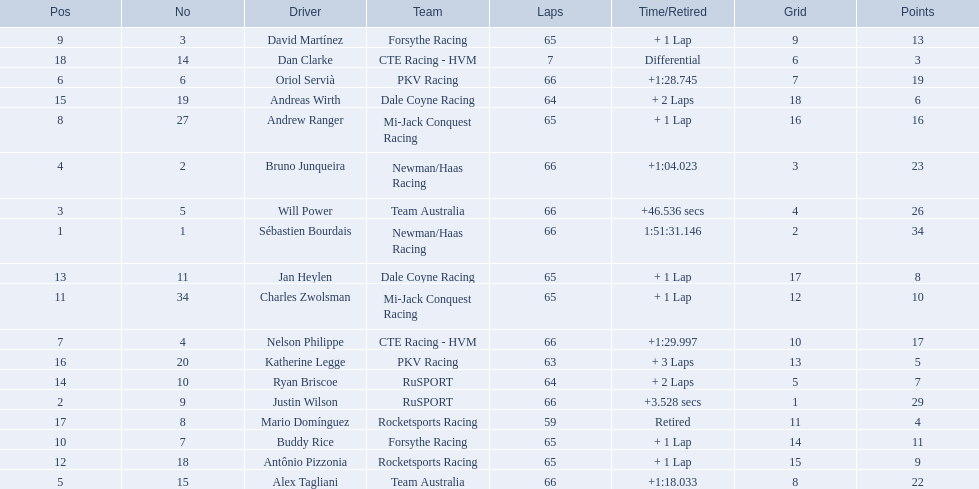Which people scored 29+ points? Sébastien Bourdais, Justin Wilson. Who scored higher? Sébastien Bourdais. Write the full table. {'header': ['Pos', 'No', 'Driver', 'Team', 'Laps', 'Time/Retired', 'Grid', 'Points'], 'rows': [['9', '3', 'David Martínez', 'Forsythe Racing', '65', '+ 1 Lap', '9', '13'], ['18', '14', 'Dan Clarke', 'CTE Racing - HVM', '7', 'Differential', '6', '3'], ['6', '6', 'Oriol Servià', 'PKV Racing', '66', '+1:28.745', '7', '19'], ['15', '19', 'Andreas Wirth', 'Dale Coyne Racing', '64', '+ 2 Laps', '18', '6'], ['8', '27', 'Andrew Ranger', 'Mi-Jack Conquest Racing', '65', '+ 1 Lap', '16', '16'], ['4', '2', 'Bruno Junqueira', 'Newman/Haas Racing', '66', '+1:04.023', '3', '23'], ['3', '5', 'Will Power', 'Team Australia', '66', '+46.536 secs', '4', '26'], ['1', '1', 'Sébastien Bourdais', 'Newman/Haas Racing', '66', '1:51:31.146', '2', '34'], ['13', '11', 'Jan Heylen', 'Dale Coyne Racing', '65', '+ 1 Lap', '17', '8'], ['11', '34', 'Charles Zwolsman', 'Mi-Jack Conquest Racing', '65', '+ 1 Lap', '12', '10'], ['7', '4', 'Nelson Philippe', 'CTE Racing - HVM', '66', '+1:29.997', '10', '17'], ['16', '20', 'Katherine Legge', 'PKV Racing', '63', '+ 3 Laps', '13', '5'], ['14', '10', 'Ryan Briscoe', 'RuSPORT', '64', '+ 2 Laps', '5', '7'], ['2', '9', 'Justin Wilson', 'RuSPORT', '66', '+3.528 secs', '1', '29'], ['17', '8', 'Mario Domínguez', 'Rocketsports Racing', '59', 'Retired', '11', '4'], ['10', '7', 'Buddy Rice', 'Forsythe Racing', '65', '+ 1 Lap', '14', '11'], ['12', '18', 'Antônio Pizzonia', 'Rocketsports Racing', '65', '+ 1 Lap', '15', '9'], ['5', '15', 'Alex Tagliani', 'Team Australia', '66', '+1:18.033', '8', '22']]} How many laps did oriol servia complete at the 2006 gran premio? 66. How many laps did katherine legge complete at the 2006 gran premio? 63. Between servia and legge, who completed more laps? Oriol Servià. 